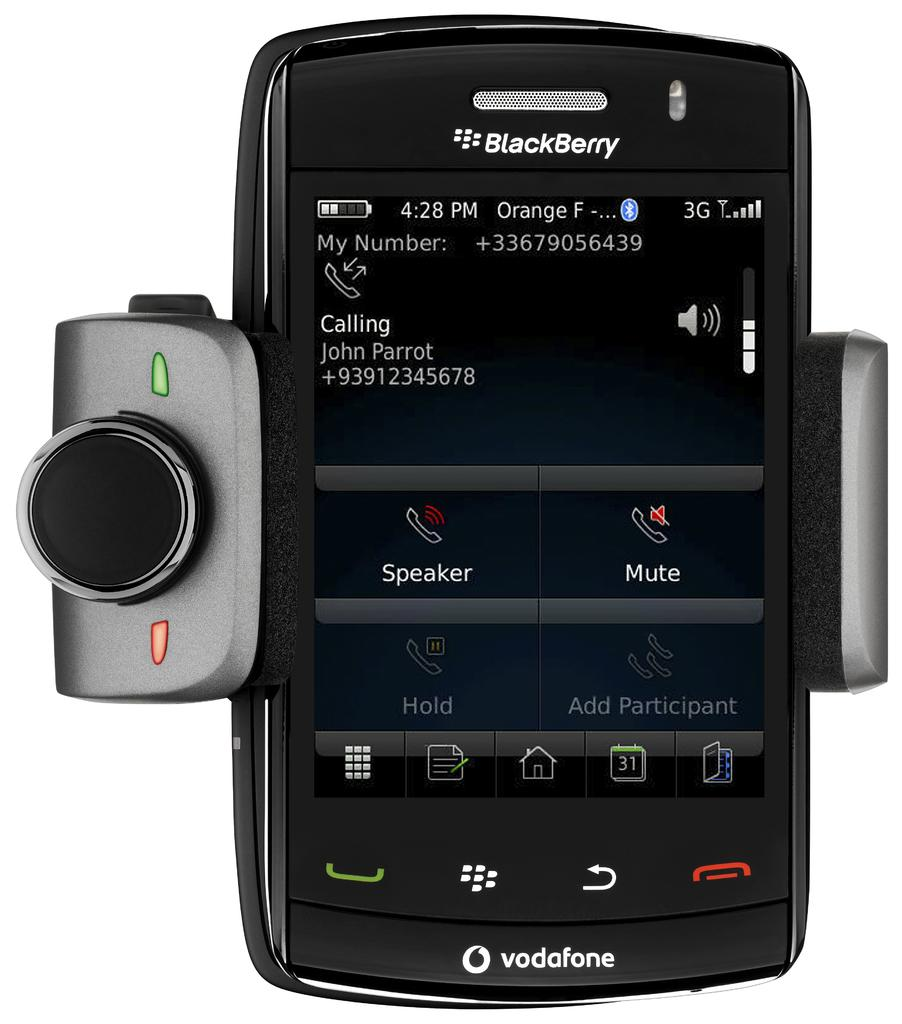<image>
Give a short and clear explanation of the subsequent image. A Blackberry screen shows Johnny Parrot's phone number. 